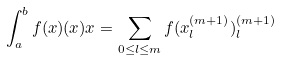<formula> <loc_0><loc_0><loc_500><loc_500>\int _ { a } ^ { b } f ( x ) ( x ) x = \sum _ { 0 \leq l \leq m } f ( x ^ { ( m + 1 ) } _ { l } ) ^ { ( m + 1 ) } _ { l }</formula> 